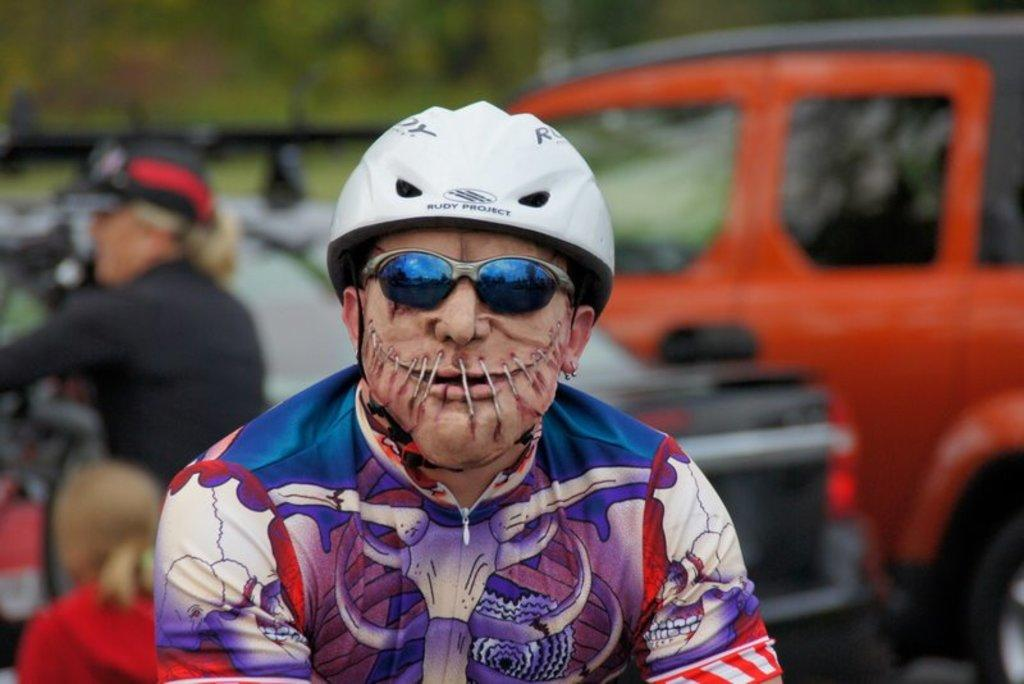Who or what can be seen in the image? There are people in the image. What else is present in the image besides the people? There are vehicles parked in the image. Can you describe the background of the image? The background of the image is blurry. What type of disgust can be seen on the people's faces in the image? There is no indication of disgust on the people's faces in the image. Can you tell me how many crates are visible in the image? There are no crates present in the image. 